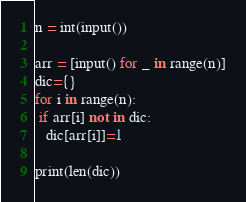Convert code to text. <code><loc_0><loc_0><loc_500><loc_500><_Python_>n = int(input())

arr = [input() for _ in range(n)]
dic={}
for i in range(n):
 if arr[i] not in dic:
   dic[arr[i]]=1

print(len(dic))
</code> 